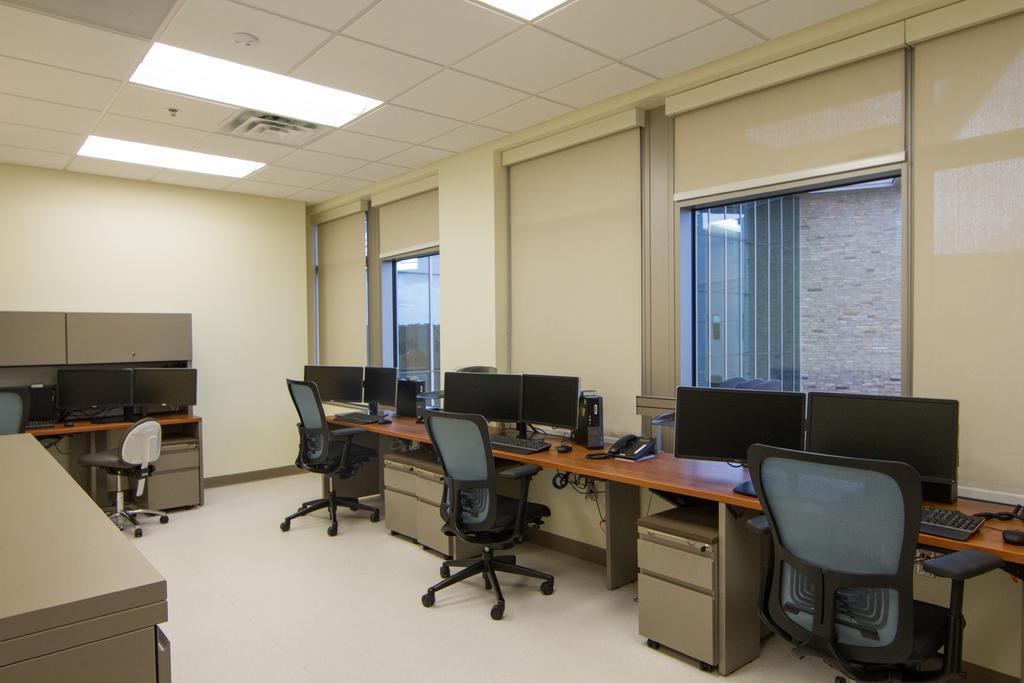Please provide a concise description of this image. This is a picture of a computer room where we have computer , keyboard , mouse , landline phone in the table and chair , at back ground we have window , and lights attached to the ceiling. 